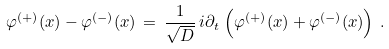<formula> <loc_0><loc_0><loc_500><loc_500>\varphi ^ { ( + ) } ( x ) - \varphi ^ { ( - ) } ( x ) \, = \, \frac { 1 } { \sqrt { D } } \, i \partial _ { t } \, \left ( \varphi ^ { ( + ) } ( x ) + \varphi ^ { ( - ) } ( x ) \right ) \, . \,</formula> 